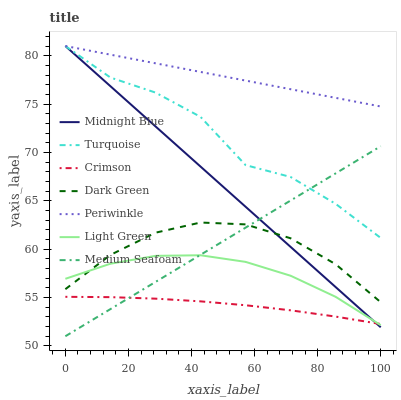Does Crimson have the minimum area under the curve?
Answer yes or no. Yes. Does Periwinkle have the maximum area under the curve?
Answer yes or no. Yes. Does Midnight Blue have the minimum area under the curve?
Answer yes or no. No. Does Midnight Blue have the maximum area under the curve?
Answer yes or no. No. Is Periwinkle the smoothest?
Answer yes or no. Yes. Is Turquoise the roughest?
Answer yes or no. Yes. Is Midnight Blue the smoothest?
Answer yes or no. No. Is Midnight Blue the roughest?
Answer yes or no. No. Does Medium Seafoam have the lowest value?
Answer yes or no. Yes. Does Midnight Blue have the lowest value?
Answer yes or no. No. Does Periwinkle have the highest value?
Answer yes or no. Yes. Does Light Green have the highest value?
Answer yes or no. No. Is Crimson less than Turquoise?
Answer yes or no. Yes. Is Periwinkle greater than Crimson?
Answer yes or no. Yes. Does Midnight Blue intersect Light Green?
Answer yes or no. Yes. Is Midnight Blue less than Light Green?
Answer yes or no. No. Is Midnight Blue greater than Light Green?
Answer yes or no. No. Does Crimson intersect Turquoise?
Answer yes or no. No. 